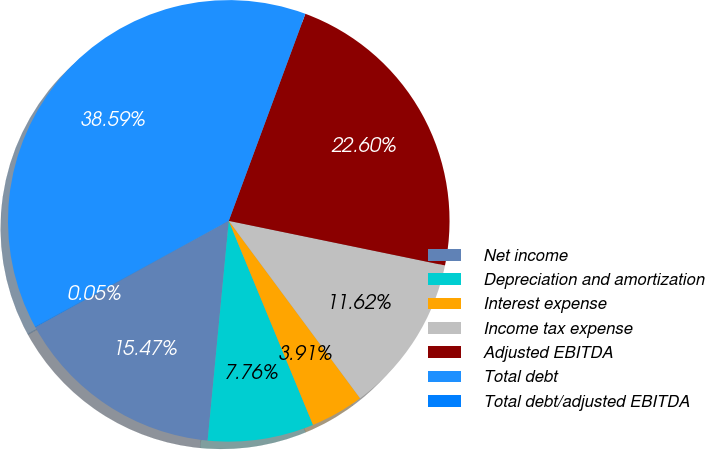Convert chart. <chart><loc_0><loc_0><loc_500><loc_500><pie_chart><fcel>Net income<fcel>Depreciation and amortization<fcel>Interest expense<fcel>Income tax expense<fcel>Adjusted EBITDA<fcel>Total debt<fcel>Total debt/adjusted EBITDA<nl><fcel>15.47%<fcel>7.76%<fcel>3.91%<fcel>11.62%<fcel>22.6%<fcel>38.59%<fcel>0.05%<nl></chart> 